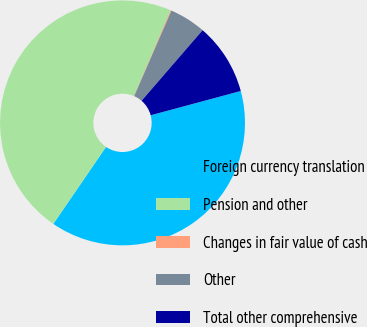Convert chart. <chart><loc_0><loc_0><loc_500><loc_500><pie_chart><fcel>Foreign currency translation<fcel>Pension and other<fcel>Changes in fair value of cash<fcel>Other<fcel>Total other comprehensive<nl><fcel>38.75%<fcel>46.86%<fcel>0.12%<fcel>4.8%<fcel>9.47%<nl></chart> 